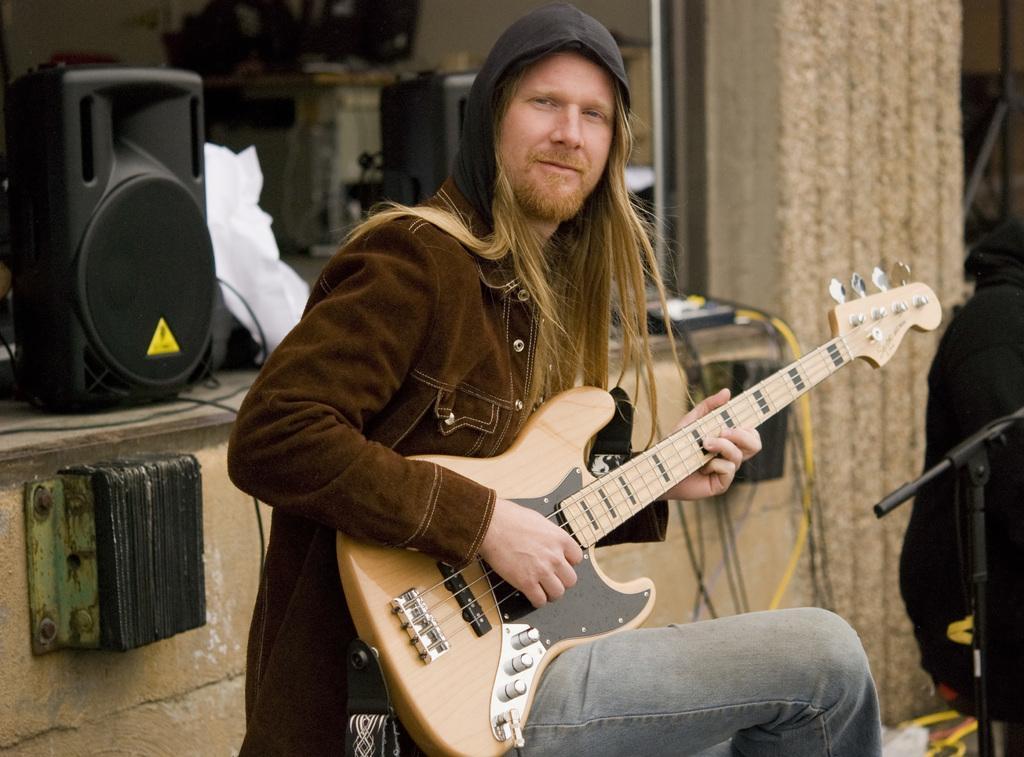In one or two sentences, can you explain what this image depicts? This is a man sitting and playing guitar. This looks like a mike stand. This is a speaker which is black in color. 